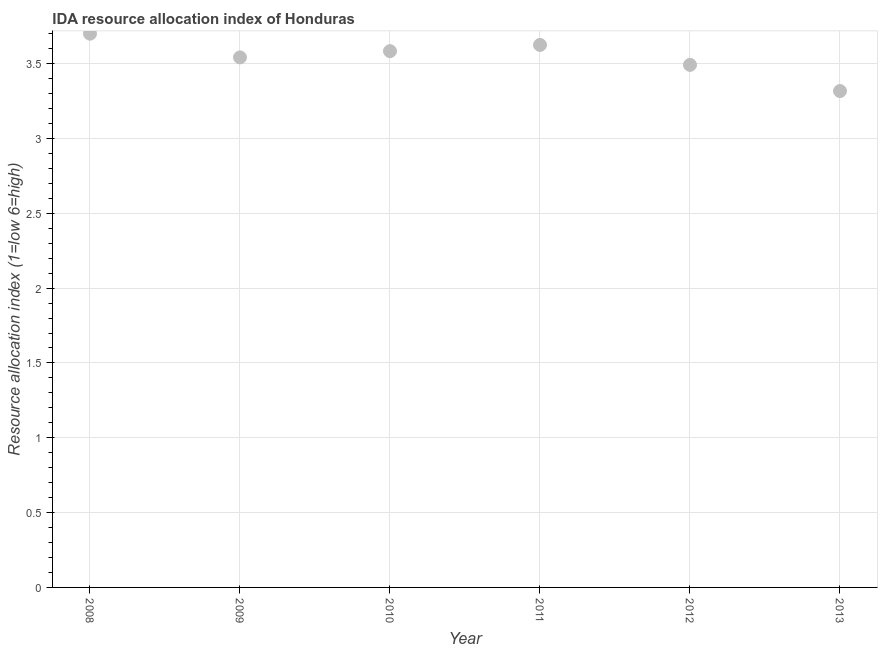What is the ida resource allocation index in 2010?
Your answer should be very brief. 3.58. Across all years, what is the minimum ida resource allocation index?
Provide a short and direct response. 3.32. In which year was the ida resource allocation index maximum?
Your answer should be compact. 2008. What is the sum of the ida resource allocation index?
Your answer should be compact. 21.26. What is the difference between the ida resource allocation index in 2010 and 2011?
Your answer should be compact. -0.04. What is the average ida resource allocation index per year?
Offer a terse response. 3.54. What is the median ida resource allocation index?
Make the answer very short. 3.56. In how many years, is the ida resource allocation index greater than 3 ?
Keep it short and to the point. 6. Do a majority of the years between 2009 and 2008 (inclusive) have ida resource allocation index greater than 2.4 ?
Make the answer very short. No. What is the ratio of the ida resource allocation index in 2011 to that in 2013?
Give a very brief answer. 1.09. What is the difference between the highest and the second highest ida resource allocation index?
Your answer should be compact. 0.08. What is the difference between the highest and the lowest ida resource allocation index?
Make the answer very short. 0.38. What is the difference between two consecutive major ticks on the Y-axis?
Ensure brevity in your answer.  0.5. Does the graph contain any zero values?
Give a very brief answer. No. What is the title of the graph?
Offer a terse response. IDA resource allocation index of Honduras. What is the label or title of the X-axis?
Make the answer very short. Year. What is the label or title of the Y-axis?
Give a very brief answer. Resource allocation index (1=low 6=high). What is the Resource allocation index (1=low 6=high) in 2009?
Your response must be concise. 3.54. What is the Resource allocation index (1=low 6=high) in 2010?
Offer a terse response. 3.58. What is the Resource allocation index (1=low 6=high) in 2011?
Make the answer very short. 3.62. What is the Resource allocation index (1=low 6=high) in 2012?
Ensure brevity in your answer.  3.49. What is the Resource allocation index (1=low 6=high) in 2013?
Offer a very short reply. 3.32. What is the difference between the Resource allocation index (1=low 6=high) in 2008 and 2009?
Your response must be concise. 0.16. What is the difference between the Resource allocation index (1=low 6=high) in 2008 and 2010?
Ensure brevity in your answer.  0.12. What is the difference between the Resource allocation index (1=low 6=high) in 2008 and 2011?
Your answer should be very brief. 0.07. What is the difference between the Resource allocation index (1=low 6=high) in 2008 and 2012?
Provide a succinct answer. 0.21. What is the difference between the Resource allocation index (1=low 6=high) in 2008 and 2013?
Your answer should be very brief. 0.38. What is the difference between the Resource allocation index (1=low 6=high) in 2009 and 2010?
Your answer should be compact. -0.04. What is the difference between the Resource allocation index (1=low 6=high) in 2009 and 2011?
Offer a terse response. -0.08. What is the difference between the Resource allocation index (1=low 6=high) in 2009 and 2013?
Ensure brevity in your answer.  0.23. What is the difference between the Resource allocation index (1=low 6=high) in 2010 and 2011?
Provide a short and direct response. -0.04. What is the difference between the Resource allocation index (1=low 6=high) in 2010 and 2012?
Your answer should be very brief. 0.09. What is the difference between the Resource allocation index (1=low 6=high) in 2010 and 2013?
Give a very brief answer. 0.27. What is the difference between the Resource allocation index (1=low 6=high) in 2011 and 2012?
Offer a very short reply. 0.13. What is the difference between the Resource allocation index (1=low 6=high) in 2011 and 2013?
Ensure brevity in your answer.  0.31. What is the difference between the Resource allocation index (1=low 6=high) in 2012 and 2013?
Ensure brevity in your answer.  0.17. What is the ratio of the Resource allocation index (1=low 6=high) in 2008 to that in 2009?
Your response must be concise. 1.04. What is the ratio of the Resource allocation index (1=low 6=high) in 2008 to that in 2010?
Keep it short and to the point. 1.03. What is the ratio of the Resource allocation index (1=low 6=high) in 2008 to that in 2011?
Offer a very short reply. 1.02. What is the ratio of the Resource allocation index (1=low 6=high) in 2008 to that in 2012?
Give a very brief answer. 1.06. What is the ratio of the Resource allocation index (1=low 6=high) in 2008 to that in 2013?
Give a very brief answer. 1.12. What is the ratio of the Resource allocation index (1=low 6=high) in 2009 to that in 2010?
Make the answer very short. 0.99. What is the ratio of the Resource allocation index (1=low 6=high) in 2009 to that in 2011?
Your answer should be compact. 0.98. What is the ratio of the Resource allocation index (1=low 6=high) in 2009 to that in 2012?
Offer a very short reply. 1.01. What is the ratio of the Resource allocation index (1=low 6=high) in 2009 to that in 2013?
Provide a succinct answer. 1.07. What is the ratio of the Resource allocation index (1=low 6=high) in 2010 to that in 2012?
Ensure brevity in your answer.  1.03. What is the ratio of the Resource allocation index (1=low 6=high) in 2011 to that in 2012?
Make the answer very short. 1.04. What is the ratio of the Resource allocation index (1=low 6=high) in 2011 to that in 2013?
Offer a very short reply. 1.09. What is the ratio of the Resource allocation index (1=low 6=high) in 2012 to that in 2013?
Make the answer very short. 1.05. 